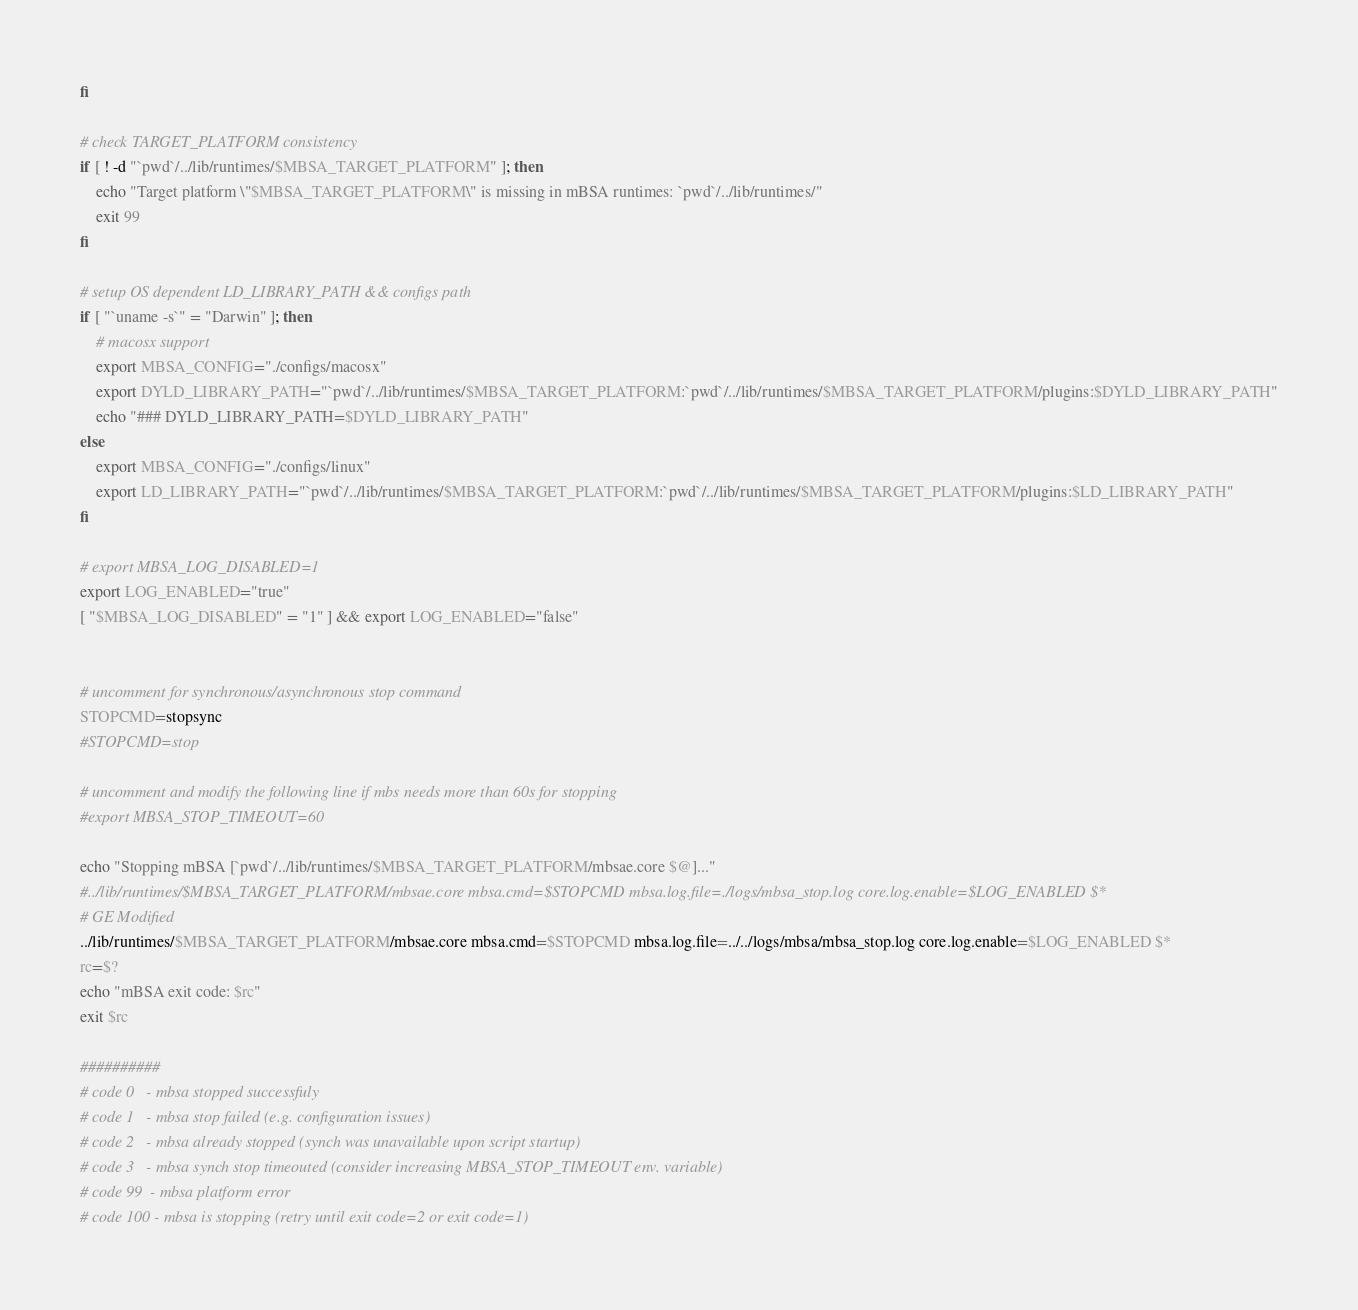Convert code to text. <code><loc_0><loc_0><loc_500><loc_500><_Bash_>fi

# check TARGET_PLATFORM consistency
if [ ! -d "`pwd`/../lib/runtimes/$MBSA_TARGET_PLATFORM" ]; then
	echo "Target platform \"$MBSA_TARGET_PLATFORM\" is missing in mBSA runtimes: `pwd`/../lib/runtimes/"
	exit 99
fi

# setup OS dependent LD_LIBRARY_PATH && configs path
if [ "`uname -s`" = "Darwin" ]; then
    # macosx support
	export MBSA_CONFIG="./configs/macosx"
    export DYLD_LIBRARY_PATH="`pwd`/../lib/runtimes/$MBSA_TARGET_PLATFORM:`pwd`/../lib/runtimes/$MBSA_TARGET_PLATFORM/plugins:$DYLD_LIBRARY_PATH"
    echo "### DYLD_LIBRARY_PATH=$DYLD_LIBRARY_PATH"
else
	export MBSA_CONFIG="./configs/linux"
	export LD_LIBRARY_PATH="`pwd`/../lib/runtimes/$MBSA_TARGET_PLATFORM:`pwd`/../lib/runtimes/$MBSA_TARGET_PLATFORM/plugins:$LD_LIBRARY_PATH"
fi

# export MBSA_LOG_DISABLED=1
export LOG_ENABLED="true"
[ "$MBSA_LOG_DISABLED" = "1" ] && export LOG_ENABLED="false" 


# uncomment for synchronous/asynchronous stop command
STOPCMD=stopsync
#STOPCMD=stop

# uncomment and modify the following line if mbs needs more than 60s for stopping
#export MBSA_STOP_TIMEOUT=60

echo "Stopping mBSA [`pwd`/../lib/runtimes/$MBSA_TARGET_PLATFORM/mbsae.core $@]..."
#../lib/runtimes/$MBSA_TARGET_PLATFORM/mbsae.core mbsa.cmd=$STOPCMD mbsa.log.file=./logs/mbsa_stop.log core.log.enable=$LOG_ENABLED $*
# GE Modified
../lib/runtimes/$MBSA_TARGET_PLATFORM/mbsae.core mbsa.cmd=$STOPCMD mbsa.log.file=../../logs/mbsa/mbsa_stop.log core.log.enable=$LOG_ENABLED $*
rc=$?
echo "mBSA exit code: $rc"
exit $rc

##########
# code 0   - mbsa stopped successfuly
# code 1   - mbsa stop failed (e.g. configuration issues)
# code 2   - mbsa already stopped (synch was unavailable upon script startup)
# code 3   - mbsa synch stop timeouted (consider increasing MBSA_STOP_TIMEOUT env. variable)
# code 99  - mbsa platform error
# code 100 - mbsa is stopping (retry until exit code=2 or exit code=1)
</code> 